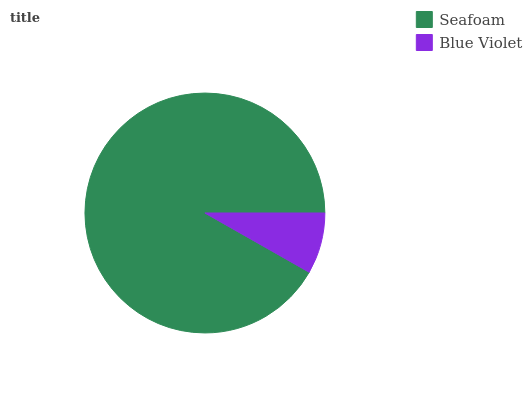Is Blue Violet the minimum?
Answer yes or no. Yes. Is Seafoam the maximum?
Answer yes or no. Yes. Is Blue Violet the maximum?
Answer yes or no. No. Is Seafoam greater than Blue Violet?
Answer yes or no. Yes. Is Blue Violet less than Seafoam?
Answer yes or no. Yes. Is Blue Violet greater than Seafoam?
Answer yes or no. No. Is Seafoam less than Blue Violet?
Answer yes or no. No. Is Seafoam the high median?
Answer yes or no. Yes. Is Blue Violet the low median?
Answer yes or no. Yes. Is Blue Violet the high median?
Answer yes or no. No. Is Seafoam the low median?
Answer yes or no. No. 